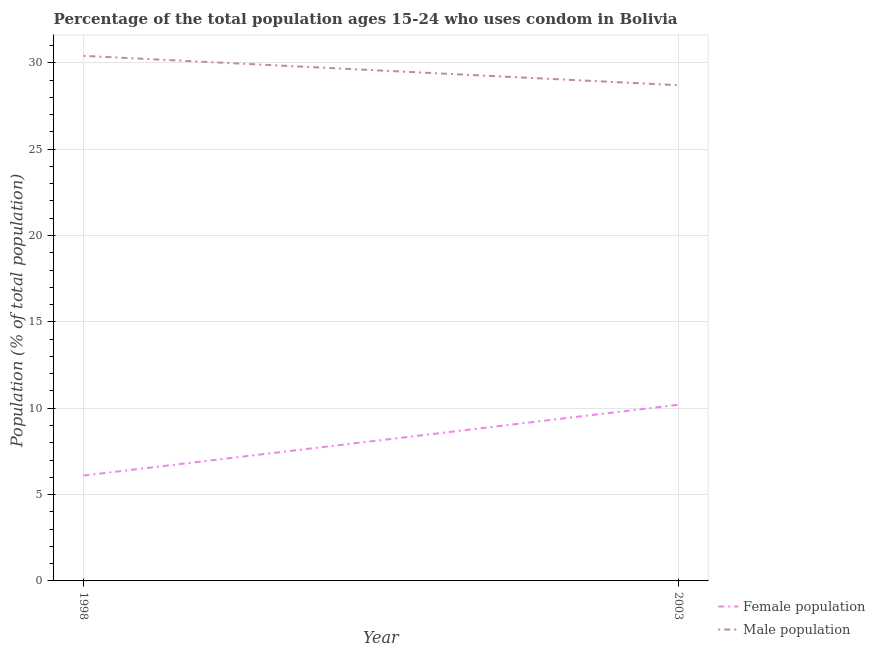Does the line corresponding to female population intersect with the line corresponding to male population?
Make the answer very short. No. What is the male population in 2003?
Give a very brief answer. 28.7. Across all years, what is the maximum male population?
Your answer should be compact. 30.4. Across all years, what is the minimum female population?
Your answer should be compact. 6.1. In which year was the female population maximum?
Your response must be concise. 2003. In which year was the male population minimum?
Provide a succinct answer. 2003. What is the total male population in the graph?
Provide a succinct answer. 59.1. What is the difference between the male population in 1998 and that in 2003?
Offer a terse response. 1.7. What is the difference between the male population in 2003 and the female population in 1998?
Keep it short and to the point. 22.6. What is the average female population per year?
Your answer should be very brief. 8.15. In the year 1998, what is the difference between the female population and male population?
Provide a short and direct response. -24.3. What is the ratio of the female population in 1998 to that in 2003?
Your answer should be compact. 0.6. In how many years, is the female population greater than the average female population taken over all years?
Your answer should be very brief. 1. Does the male population monotonically increase over the years?
Make the answer very short. No. Is the male population strictly less than the female population over the years?
Provide a short and direct response. No. Does the graph contain any zero values?
Keep it short and to the point. No. Where does the legend appear in the graph?
Your response must be concise. Bottom right. What is the title of the graph?
Keep it short and to the point. Percentage of the total population ages 15-24 who uses condom in Bolivia. Does "Male entrants" appear as one of the legend labels in the graph?
Ensure brevity in your answer.  No. What is the label or title of the X-axis?
Your response must be concise. Year. What is the label or title of the Y-axis?
Ensure brevity in your answer.  Population (% of total population) . What is the Population (% of total population)  in Male population in 1998?
Your answer should be compact. 30.4. What is the Population (% of total population)  of Female population in 2003?
Keep it short and to the point. 10.2. What is the Population (% of total population)  in Male population in 2003?
Provide a short and direct response. 28.7. Across all years, what is the maximum Population (% of total population)  in Female population?
Provide a short and direct response. 10.2. Across all years, what is the maximum Population (% of total population)  of Male population?
Offer a terse response. 30.4. Across all years, what is the minimum Population (% of total population)  in Female population?
Your answer should be very brief. 6.1. Across all years, what is the minimum Population (% of total population)  of Male population?
Keep it short and to the point. 28.7. What is the total Population (% of total population)  in Male population in the graph?
Ensure brevity in your answer.  59.1. What is the difference between the Population (% of total population)  of Female population in 1998 and the Population (% of total population)  of Male population in 2003?
Your response must be concise. -22.6. What is the average Population (% of total population)  in Female population per year?
Offer a terse response. 8.15. What is the average Population (% of total population)  in Male population per year?
Your answer should be compact. 29.55. In the year 1998, what is the difference between the Population (% of total population)  in Female population and Population (% of total population)  in Male population?
Provide a short and direct response. -24.3. In the year 2003, what is the difference between the Population (% of total population)  of Female population and Population (% of total population)  of Male population?
Ensure brevity in your answer.  -18.5. What is the ratio of the Population (% of total population)  in Female population in 1998 to that in 2003?
Offer a terse response. 0.6. What is the ratio of the Population (% of total population)  of Male population in 1998 to that in 2003?
Provide a short and direct response. 1.06. What is the difference between the highest and the lowest Population (% of total population)  in Male population?
Keep it short and to the point. 1.7. 